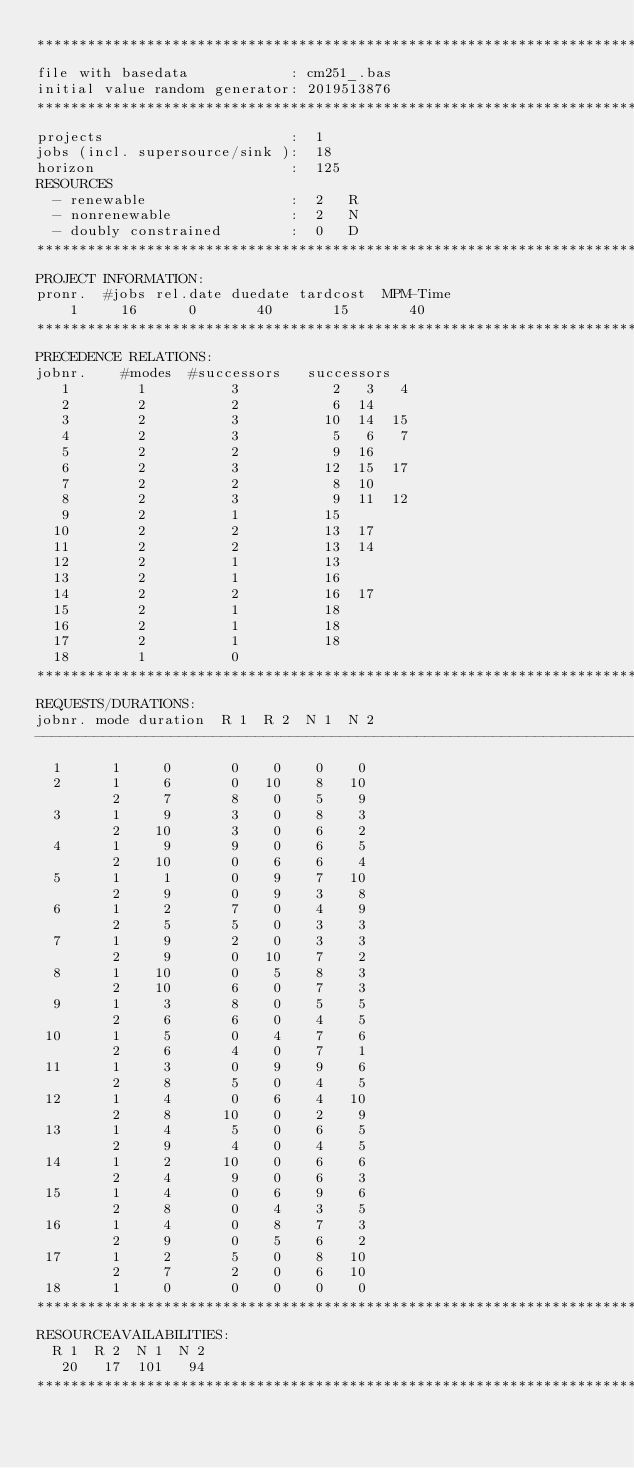Convert code to text. <code><loc_0><loc_0><loc_500><loc_500><_ObjectiveC_>************************************************************************
file with basedata            : cm251_.bas
initial value random generator: 2019513876
************************************************************************
projects                      :  1
jobs (incl. supersource/sink ):  18
horizon                       :  125
RESOURCES
  - renewable                 :  2   R
  - nonrenewable              :  2   N
  - doubly constrained        :  0   D
************************************************************************
PROJECT INFORMATION:
pronr.  #jobs rel.date duedate tardcost  MPM-Time
    1     16      0       40       15       40
************************************************************************
PRECEDENCE RELATIONS:
jobnr.    #modes  #successors   successors
   1        1          3           2   3   4
   2        2          2           6  14
   3        2          3          10  14  15
   4        2          3           5   6   7
   5        2          2           9  16
   6        2          3          12  15  17
   7        2          2           8  10
   8        2          3           9  11  12
   9        2          1          15
  10        2          2          13  17
  11        2          2          13  14
  12        2          1          13
  13        2          1          16
  14        2          2          16  17
  15        2          1          18
  16        2          1          18
  17        2          1          18
  18        1          0        
************************************************************************
REQUESTS/DURATIONS:
jobnr. mode duration  R 1  R 2  N 1  N 2
------------------------------------------------------------------------
  1      1     0       0    0    0    0
  2      1     6       0   10    8   10
         2     7       8    0    5    9
  3      1     9       3    0    8    3
         2    10       3    0    6    2
  4      1     9       9    0    6    5
         2    10       0    6    6    4
  5      1     1       0    9    7   10
         2     9       0    9    3    8
  6      1     2       7    0    4    9
         2     5       5    0    3    3
  7      1     9       2    0    3    3
         2     9       0   10    7    2
  8      1    10       0    5    8    3
         2    10       6    0    7    3
  9      1     3       8    0    5    5
         2     6       6    0    4    5
 10      1     5       0    4    7    6
         2     6       4    0    7    1
 11      1     3       0    9    9    6
         2     8       5    0    4    5
 12      1     4       0    6    4   10
         2     8      10    0    2    9
 13      1     4       5    0    6    5
         2     9       4    0    4    5
 14      1     2      10    0    6    6
         2     4       9    0    6    3
 15      1     4       0    6    9    6
         2     8       0    4    3    5
 16      1     4       0    8    7    3
         2     9       0    5    6    2
 17      1     2       5    0    8   10
         2     7       2    0    6   10
 18      1     0       0    0    0    0
************************************************************************
RESOURCEAVAILABILITIES:
  R 1  R 2  N 1  N 2
   20   17  101   94
************************************************************************
</code> 